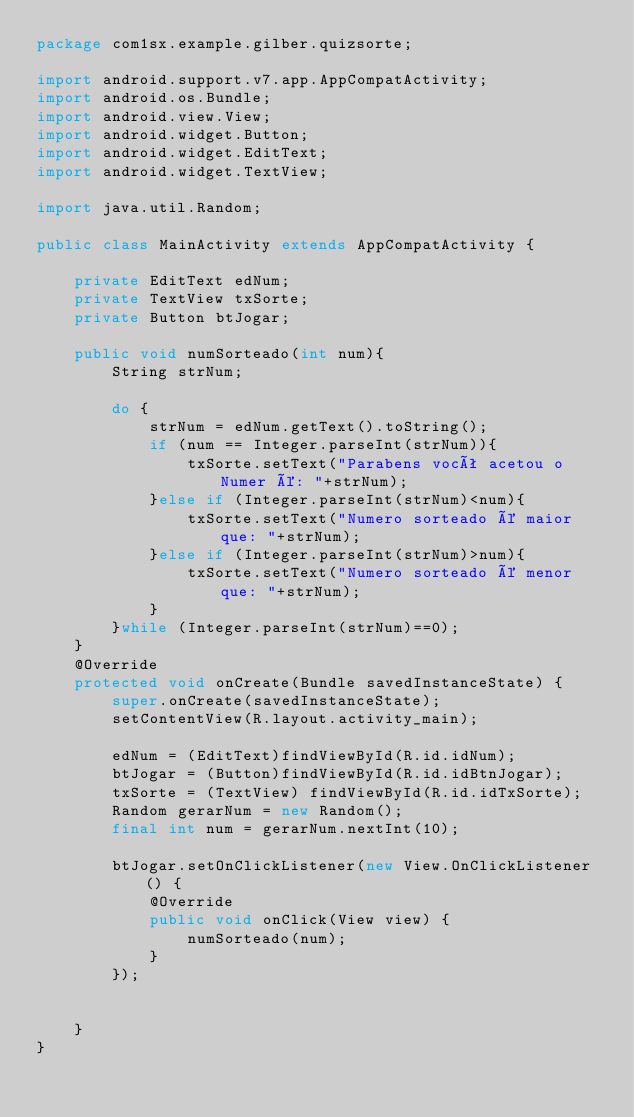<code> <loc_0><loc_0><loc_500><loc_500><_Java_>package com1sx.example.gilber.quizsorte;

import android.support.v7.app.AppCompatActivity;
import android.os.Bundle;
import android.view.View;
import android.widget.Button;
import android.widget.EditText;
import android.widget.TextView;

import java.util.Random;

public class MainActivity extends AppCompatActivity {

    private EditText edNum;
    private TextView txSorte;
    private Button btJogar;

    public void numSorteado(int num){
        String strNum;

        do {
            strNum = edNum.getText().toString();
            if (num == Integer.parseInt(strNum)){
                txSorte.setText("Parabens você acetou o Numer é: "+strNum);
            }else if (Integer.parseInt(strNum)<num){
                txSorte.setText("Numero sorteado é maior que: "+strNum);
            }else if (Integer.parseInt(strNum)>num){
                txSorte.setText("Numero sorteado é menor que: "+strNum);
            }
        }while (Integer.parseInt(strNum)==0);
    }
    @Override
    protected void onCreate(Bundle savedInstanceState) {
        super.onCreate(savedInstanceState);
        setContentView(R.layout.activity_main);

        edNum = (EditText)findViewById(R.id.idNum);
        btJogar = (Button)findViewById(R.id.idBtnJogar);
        txSorte = (TextView) findViewById(R.id.idTxSorte);
        Random gerarNum = new Random();
        final int num = gerarNum.nextInt(10);

        btJogar.setOnClickListener(new View.OnClickListener() {
            @Override
            public void onClick(View view) {
                numSorteado(num);
            }
        });


    }
}
</code> 